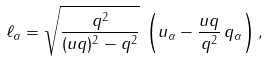Convert formula to latex. <formula><loc_0><loc_0><loc_500><loc_500>\ell _ { \alpha } = \sqrt { \frac { q ^ { 2 } } { ( u q ) ^ { 2 } - q ^ { 2 } } } \, \left ( u _ { \alpha } - \frac { u q } { q ^ { 2 } } \, q _ { \alpha } \right ) ,</formula> 